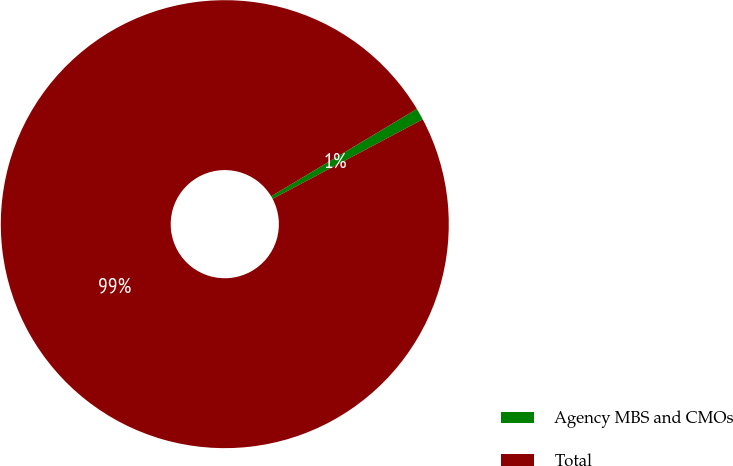Convert chart to OTSL. <chart><loc_0><loc_0><loc_500><loc_500><pie_chart><fcel>Agency MBS and CMOs<fcel>Total<nl><fcel>0.85%<fcel>99.15%<nl></chart> 